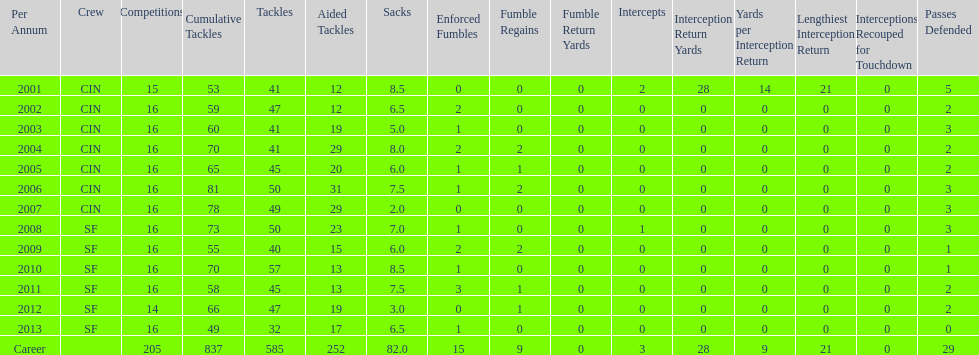Give me the full table as a dictionary. {'header': ['Per Annum', 'Crew', 'Competitions', 'Cumulative Tackles', 'Tackles', 'Aided Tackles', 'Sacks', 'Enforced Fumbles', 'Fumble Regains', 'Fumble Return Yards', 'Intercepts', 'Interception Return Yards', 'Yards per Interception Return', 'Lengthiest Interception Return', 'Interceptions Recouped for Touchdown', 'Passes Defended'], 'rows': [['2001', 'CIN', '15', '53', '41', '12', '8.5', '0', '0', '0', '2', '28', '14', '21', '0', '5'], ['2002', 'CIN', '16', '59', '47', '12', '6.5', '2', '0', '0', '0', '0', '0', '0', '0', '2'], ['2003', 'CIN', '16', '60', '41', '19', '5.0', '1', '0', '0', '0', '0', '0', '0', '0', '3'], ['2004', 'CIN', '16', '70', '41', '29', '8.0', '2', '2', '0', '0', '0', '0', '0', '0', '2'], ['2005', 'CIN', '16', '65', '45', '20', '6.0', '1', '1', '0', '0', '0', '0', '0', '0', '2'], ['2006', 'CIN', '16', '81', '50', '31', '7.5', '1', '2', '0', '0', '0', '0', '0', '0', '3'], ['2007', 'CIN', '16', '78', '49', '29', '2.0', '0', '0', '0', '0', '0', '0', '0', '0', '3'], ['2008', 'SF', '16', '73', '50', '23', '7.0', '1', '0', '0', '1', '0', '0', '0', '0', '3'], ['2009', 'SF', '16', '55', '40', '15', '6.0', '2', '2', '0', '0', '0', '0', '0', '0', '1'], ['2010', 'SF', '16', '70', '57', '13', '8.5', '1', '0', '0', '0', '0', '0', '0', '0', '1'], ['2011', 'SF', '16', '58', '45', '13', '7.5', '3', '1', '0', '0', '0', '0', '0', '0', '2'], ['2012', 'SF', '14', '66', '47', '19', '3.0', '0', '1', '0', '0', '0', '0', '0', '0', '2'], ['2013', 'SF', '16', '49', '32', '17', '6.5', '1', '0', '0', '0', '0', '0', '0', '0', '0'], ['Career', '', '205', '837', '585', '252', '82.0', '15', '9', '0', '3', '28', '9', '21', '0', '29']]} How many seasons had combined tackles of 70 or more? 5. 